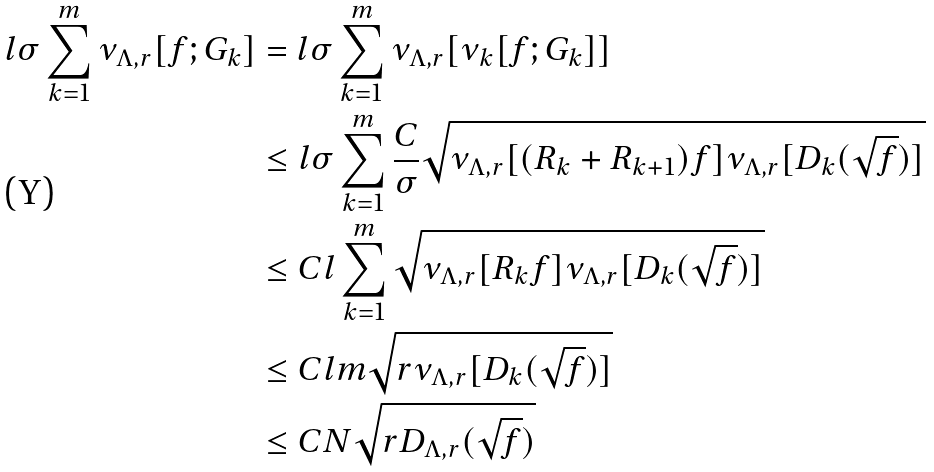Convert formula to latex. <formula><loc_0><loc_0><loc_500><loc_500>l \sigma \sum _ { k = 1 } ^ { m } \nu _ { \Lambda , r } [ f ; G _ { k } ] & = l \sigma \sum _ { k = 1 } ^ { m } \nu _ { \Lambda , r } [ \nu _ { k } [ f ; G _ { k } ] ] \\ & \leq l \sigma \sum _ { k = 1 } ^ { m } \frac { C } { \sigma } \sqrt { \nu _ { \Lambda , r } [ ( R _ { k } + R _ { k + 1 } ) f ] \nu _ { \Lambda , r } [ D _ { k } ( { \sqrt { f } } ) ] } \\ & \leq C l \sum _ { k = 1 } ^ { m } \sqrt { \nu _ { \Lambda , r } [ R _ { k } f ] \nu _ { \Lambda , r } [ D _ { k } ( { \sqrt { f } } ) ] } \\ & \leq C l m \sqrt { r \nu _ { \Lambda , r } [ D _ { k } ( { \sqrt { f } } ) ] } \\ & \leq C N \sqrt { r D _ { \Lambda , r } ( { \sqrt { f } } ) }</formula> 